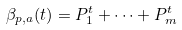<formula> <loc_0><loc_0><loc_500><loc_500>\beta _ { p , a } ( t ) = P _ { 1 } ^ { t } + \dots + P _ { m } ^ { t }</formula> 